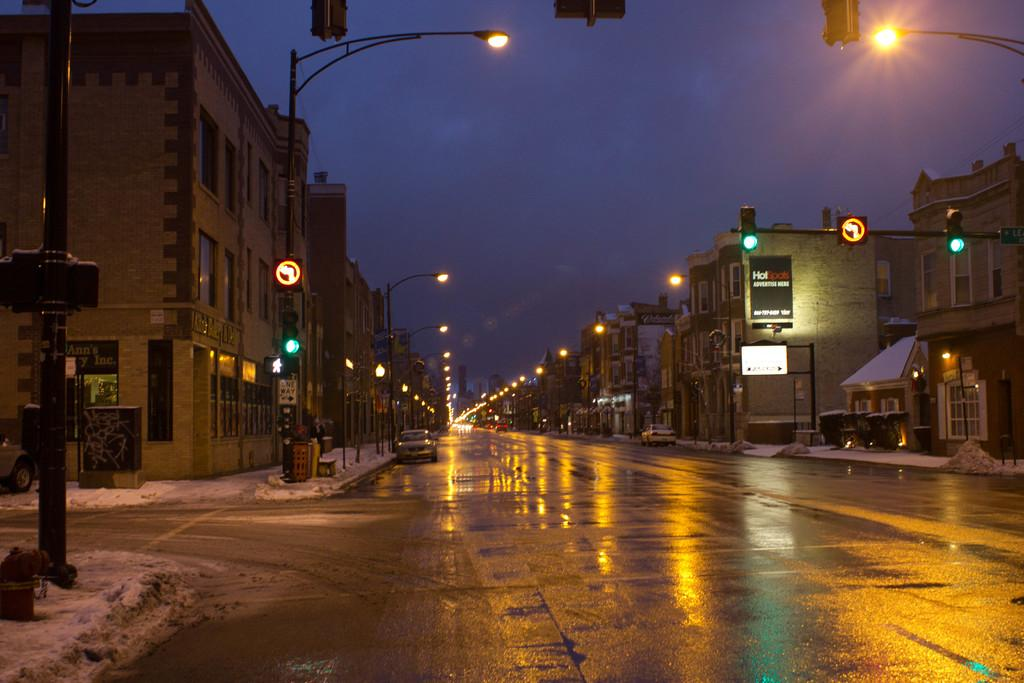What can be seen on the road in the image? There are vehicles on the road in the image. What helps to illuminate the road at night in the image? There are street lights in the image. How do the vehicles know when to stop or go in the image? There are traffic signals in the image. What can be seen in the distance in the image? There are buildings in the background of the image. What type of surprise is being delivered by the bomb in the image? There is no bomb present in the image; it only features vehicles, street lights, traffic signals, and buildings. 